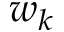<formula> <loc_0><loc_0><loc_500><loc_500>w _ { k }</formula> 